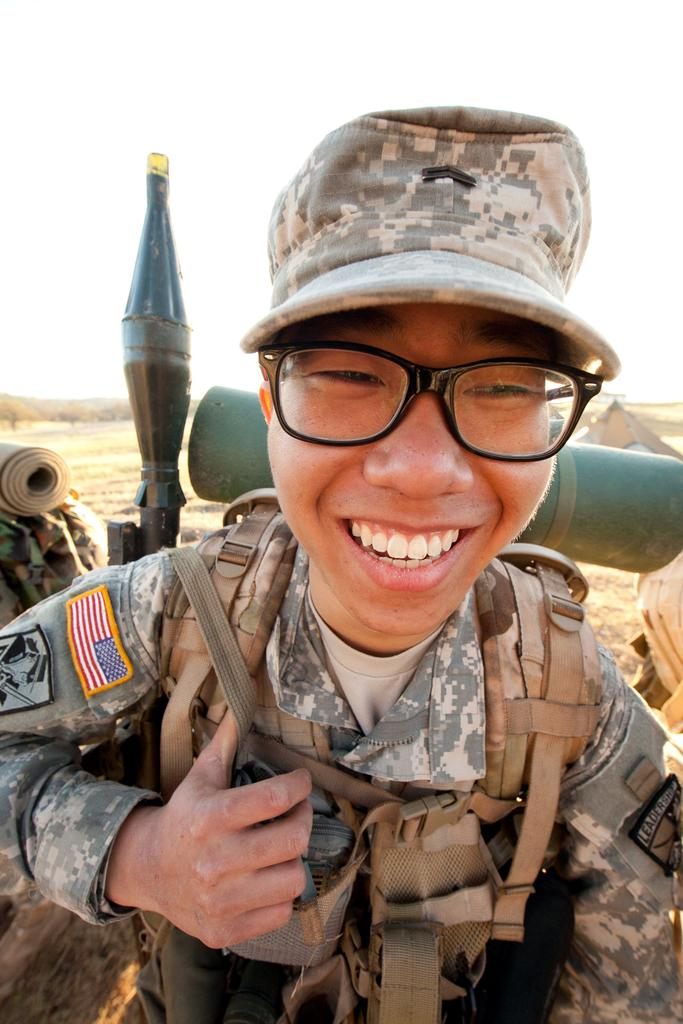What can be seen in the image? There is a person in the image. Can you describe the person's appearance? The person is wearing a cap and glasses. What is the person carrying in the image? The person is carrying a bag. What structure is visible in the image? There is a tent visible in the image. What can be seen in the background of the image? There are mountains in the background of the image. What part of the natural environment is visible in the image? The sky is visible in the image. What type of pleasure can be seen in the image? There is no specific pleasure depicted in the image; it shows a person wearing a cap, glasses, and carrying a bag, along with a tent and mountains in the background. 